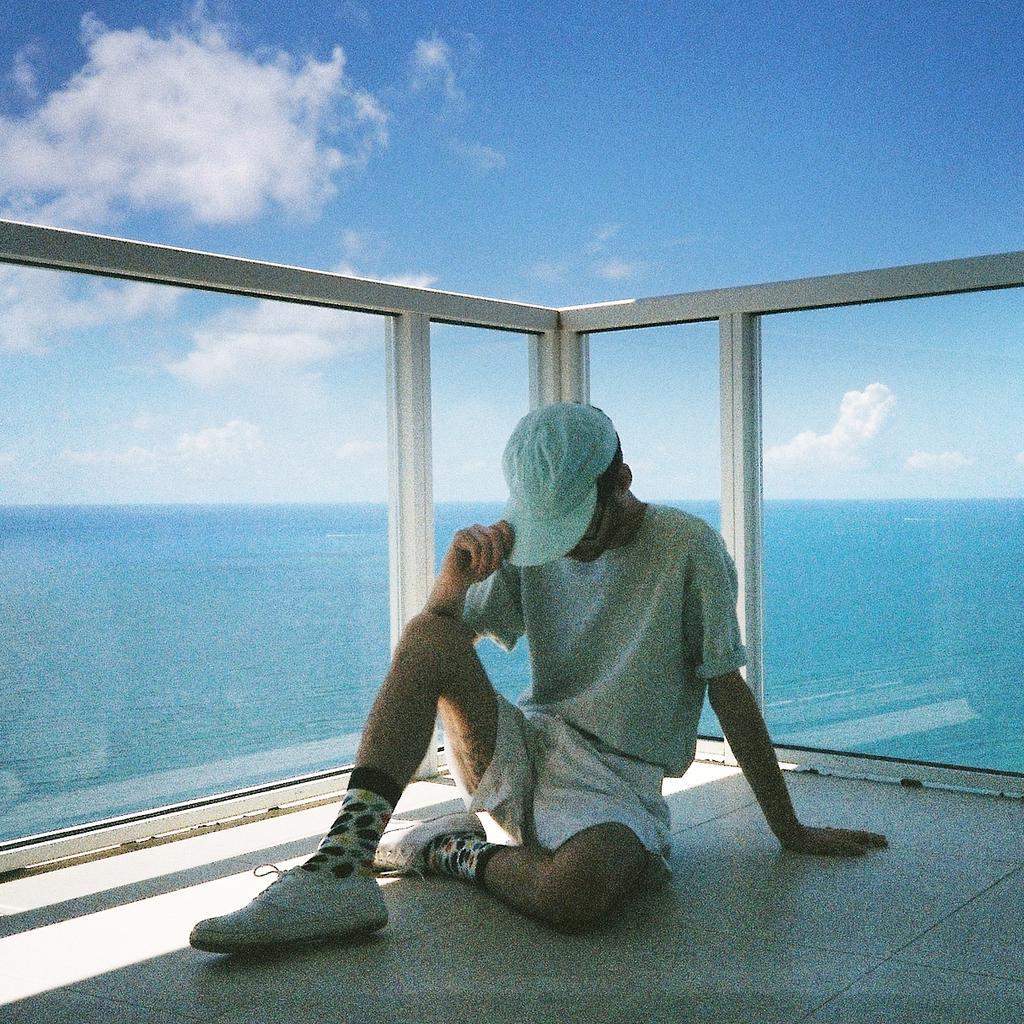In one or two sentences, can you explain what this image depicts? In the image there is a man with cap and shoes is sitting on the floor. Behind him there is a glass railing. Behind the railing there is water. At the top of the image there is a sky with clouds. 